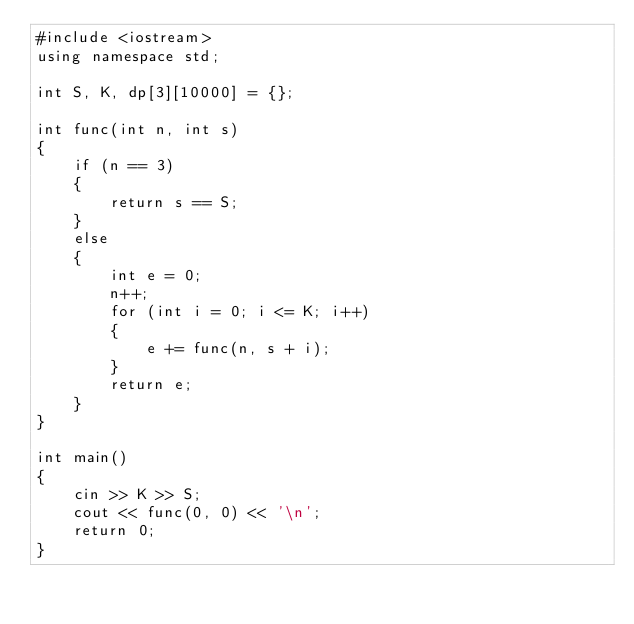<code> <loc_0><loc_0><loc_500><loc_500><_C++_>#include <iostream>
using namespace std;

int S, K, dp[3][10000] = {};

int func(int n, int s)
{
	if (n == 3)
	{
		return s == S;
	}
	else
	{
		int e = 0;
		n++;
		for (int i = 0; i <= K; i++)
		{
			e += func(n, s + i);
		}
		return e;
	}
}

int main()
{
	cin >> K >> S;
	cout << func(0, 0) << '\n';
	return 0;
}</code> 